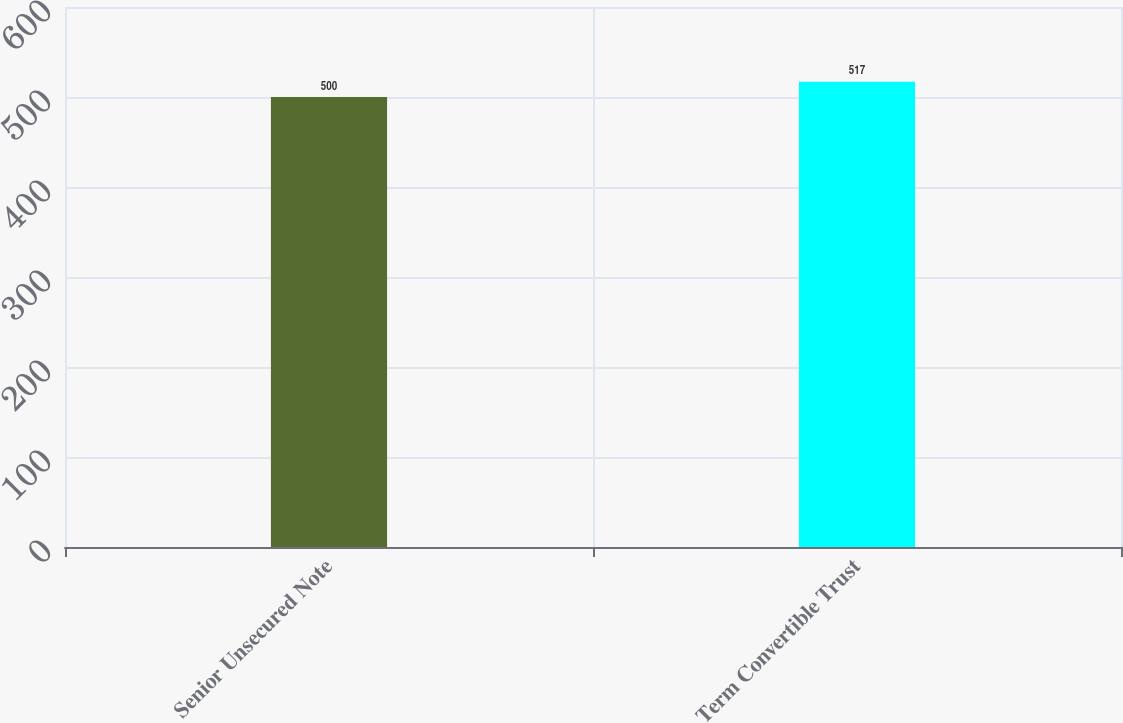Convert chart. <chart><loc_0><loc_0><loc_500><loc_500><bar_chart><fcel>Senior Unsecured Note<fcel>Term Convertible Trust<nl><fcel>500<fcel>517<nl></chart> 